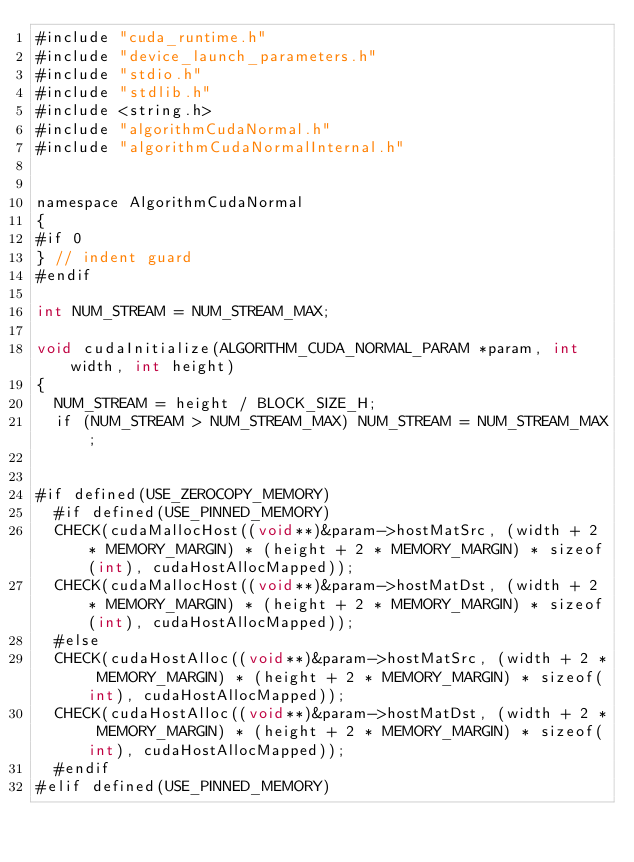<code> <loc_0><loc_0><loc_500><loc_500><_Cuda_>#include "cuda_runtime.h"
#include "device_launch_parameters.h"
#include "stdio.h"
#include "stdlib.h"
#include <string.h>
#include "algorithmCudaNormal.h"
#include "algorithmCudaNormalInternal.h"


namespace AlgorithmCudaNormal
{
#if 0
}	// indent guard
#endif

int NUM_STREAM = NUM_STREAM_MAX;

void cudaInitialize(ALGORITHM_CUDA_NORMAL_PARAM *param, int width, int height)
{
	NUM_STREAM = height / BLOCK_SIZE_H;
	if (NUM_STREAM > NUM_STREAM_MAX) NUM_STREAM = NUM_STREAM_MAX;


#if defined(USE_ZEROCOPY_MEMORY)
	#if defined(USE_PINNED_MEMORY)
	CHECK(cudaMallocHost((void**)&param->hostMatSrc, (width + 2 * MEMORY_MARGIN) * (height + 2 * MEMORY_MARGIN) * sizeof(int), cudaHostAllocMapped));
	CHECK(cudaMallocHost((void**)&param->hostMatDst, (width + 2 * MEMORY_MARGIN) * (height + 2 * MEMORY_MARGIN) * sizeof(int), cudaHostAllocMapped));
	#else
	CHECK(cudaHostAlloc((void**)&param->hostMatSrc, (width + 2 * MEMORY_MARGIN) * (height + 2 * MEMORY_MARGIN) * sizeof(int), cudaHostAllocMapped));
	CHECK(cudaHostAlloc((void**)&param->hostMatDst, (width + 2 * MEMORY_MARGIN) * (height + 2 * MEMORY_MARGIN) * sizeof(int), cudaHostAllocMapped));
	#endif
#elif defined(USE_PINNED_MEMORY)</code> 